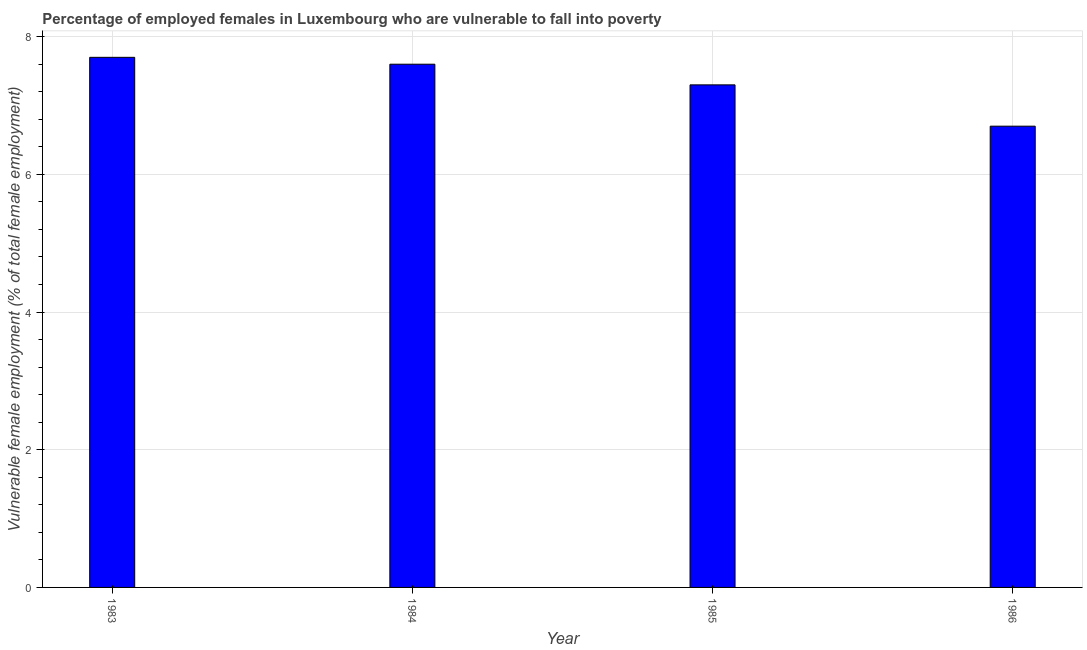What is the title of the graph?
Provide a short and direct response. Percentage of employed females in Luxembourg who are vulnerable to fall into poverty. What is the label or title of the Y-axis?
Ensure brevity in your answer.  Vulnerable female employment (% of total female employment). What is the percentage of employed females who are vulnerable to fall into poverty in 1986?
Offer a very short reply. 6.7. Across all years, what is the maximum percentage of employed females who are vulnerable to fall into poverty?
Your answer should be compact. 7.7. Across all years, what is the minimum percentage of employed females who are vulnerable to fall into poverty?
Provide a short and direct response. 6.7. In which year was the percentage of employed females who are vulnerable to fall into poverty minimum?
Your answer should be compact. 1986. What is the sum of the percentage of employed females who are vulnerable to fall into poverty?
Offer a very short reply. 29.3. What is the difference between the percentage of employed females who are vulnerable to fall into poverty in 1984 and 1985?
Ensure brevity in your answer.  0.3. What is the average percentage of employed females who are vulnerable to fall into poverty per year?
Give a very brief answer. 7.33. What is the median percentage of employed females who are vulnerable to fall into poverty?
Provide a succinct answer. 7.45. Do a majority of the years between 1985 and 1983 (inclusive) have percentage of employed females who are vulnerable to fall into poverty greater than 3.6 %?
Keep it short and to the point. Yes. What is the ratio of the percentage of employed females who are vulnerable to fall into poverty in 1984 to that in 1985?
Your response must be concise. 1.04. Is the percentage of employed females who are vulnerable to fall into poverty in 1983 less than that in 1984?
Provide a short and direct response. No. Is the sum of the percentage of employed females who are vulnerable to fall into poverty in 1983 and 1985 greater than the maximum percentage of employed females who are vulnerable to fall into poverty across all years?
Make the answer very short. Yes. What is the Vulnerable female employment (% of total female employment) in 1983?
Your answer should be very brief. 7.7. What is the Vulnerable female employment (% of total female employment) of 1984?
Your response must be concise. 7.6. What is the Vulnerable female employment (% of total female employment) of 1985?
Provide a succinct answer. 7.3. What is the Vulnerable female employment (% of total female employment) in 1986?
Your answer should be very brief. 6.7. What is the difference between the Vulnerable female employment (% of total female employment) in 1983 and 1984?
Your response must be concise. 0.1. What is the difference between the Vulnerable female employment (% of total female employment) in 1983 and 1986?
Make the answer very short. 1. What is the difference between the Vulnerable female employment (% of total female employment) in 1985 and 1986?
Offer a very short reply. 0.6. What is the ratio of the Vulnerable female employment (% of total female employment) in 1983 to that in 1984?
Your response must be concise. 1.01. What is the ratio of the Vulnerable female employment (% of total female employment) in 1983 to that in 1985?
Provide a succinct answer. 1.05. What is the ratio of the Vulnerable female employment (% of total female employment) in 1983 to that in 1986?
Offer a terse response. 1.15. What is the ratio of the Vulnerable female employment (% of total female employment) in 1984 to that in 1985?
Offer a terse response. 1.04. What is the ratio of the Vulnerable female employment (% of total female employment) in 1984 to that in 1986?
Your answer should be compact. 1.13. What is the ratio of the Vulnerable female employment (% of total female employment) in 1985 to that in 1986?
Provide a succinct answer. 1.09. 